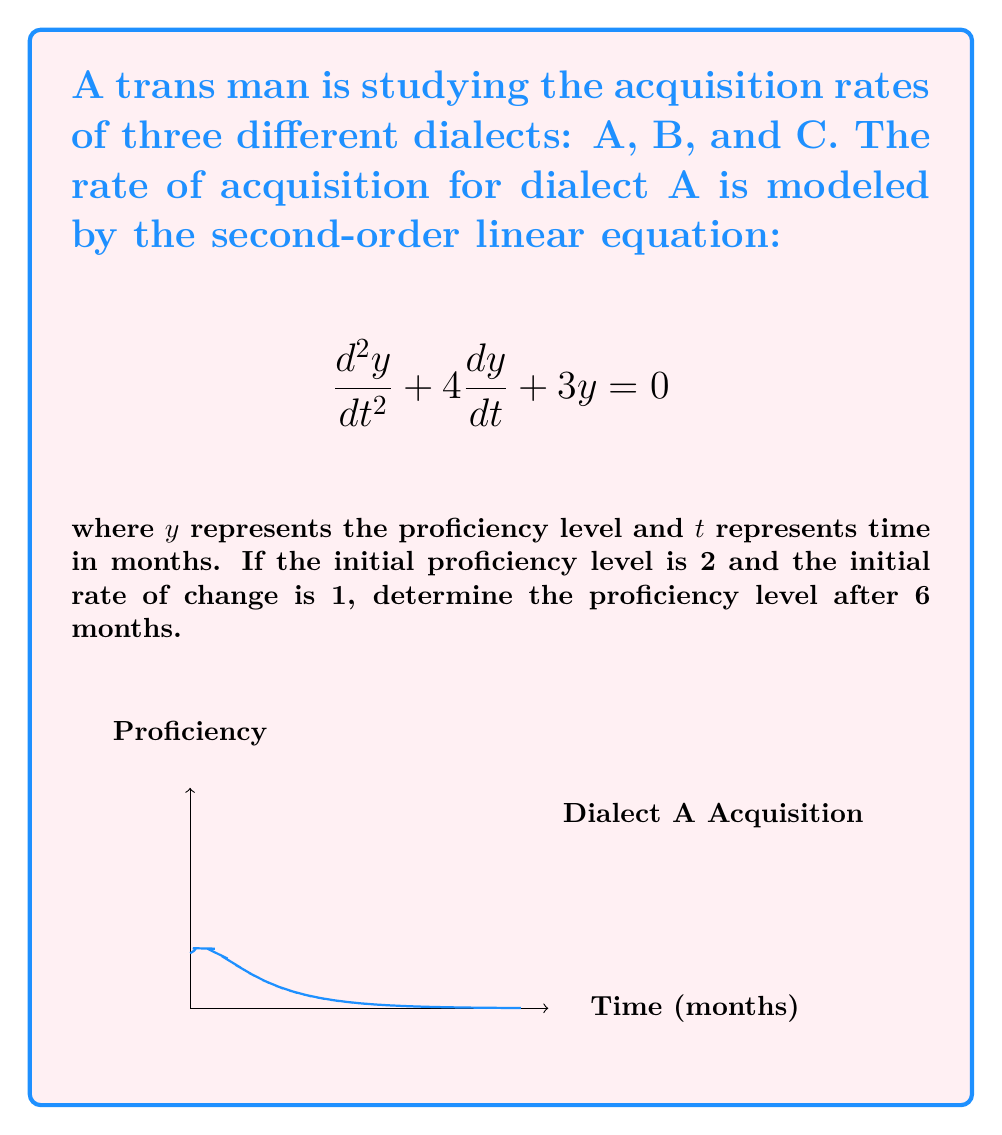Can you solve this math problem? To solve this problem, we'll follow these steps:

1) The general solution for this second-order linear equation is:
   $$y = C_1e^{-t} + C_2e^{-3t}$$

2) We need to find $C_1$ and $C_2$ using the initial conditions:
   At $t=0$, $y(0) = 2$ and $y'(0) = 1$

3) Using $y(0) = 2$:
   $$2 = C_1 + C_2$$

4) Using $y'(0) = 1$:
   $$y' = -C_1e^{-t} - 3C_2e^{-3t}$$
   $$1 = -C_1 - 3C_2$$

5) Solve the system of equations:
   $$C_1 + C_2 = 2$$
   $$C_1 + 3C_2 = -1$$
   
   Subtracting these equations:
   $$-2C_2 = -3$$
   $$C_2 = \frac{3}{2}$$
   $$C_1 = 2 - C_2 = 2 - \frac{3}{2} = \frac{1}{2}$$

6) The particular solution is:
   $$y = \frac{1}{2}e^{-t} + \frac{3}{2}e^{-3t}$$

7) To find the proficiency level after 6 months, substitute $t=6$:
   $$y(6) = \frac{1}{2}e^{-6} + \frac{3}{2}e^{-18}$$

8) Calculate the result:
   $$y(6) \approx 0.00124 + 0.00000 \approx 0.00124$$
Answer: $0.00124$ 